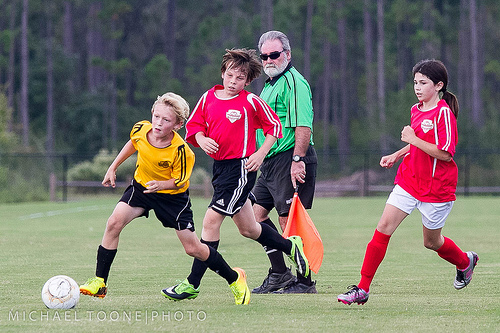<image>
Is there a ball behind the boy? No. The ball is not behind the boy. From this viewpoint, the ball appears to be positioned elsewhere in the scene. 